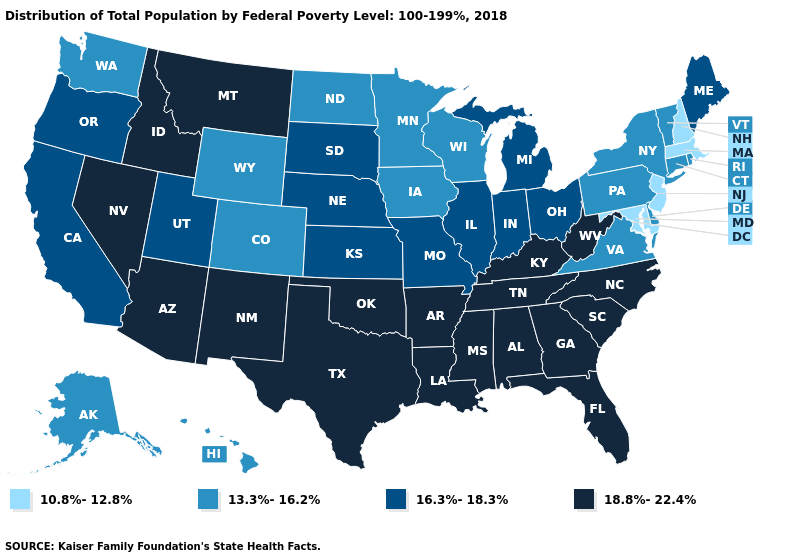Among the states that border Wisconsin , which have the highest value?
Short answer required. Illinois, Michigan. What is the highest value in the Northeast ?
Be succinct. 16.3%-18.3%. Does Indiana have the same value as New Hampshire?
Quick response, please. No. Does the map have missing data?
Keep it brief. No. Name the states that have a value in the range 13.3%-16.2%?
Short answer required. Alaska, Colorado, Connecticut, Delaware, Hawaii, Iowa, Minnesota, New York, North Dakota, Pennsylvania, Rhode Island, Vermont, Virginia, Washington, Wisconsin, Wyoming. Name the states that have a value in the range 13.3%-16.2%?
Write a very short answer. Alaska, Colorado, Connecticut, Delaware, Hawaii, Iowa, Minnesota, New York, North Dakota, Pennsylvania, Rhode Island, Vermont, Virginia, Washington, Wisconsin, Wyoming. What is the highest value in states that border Ohio?
Answer briefly. 18.8%-22.4%. Does the map have missing data?
Short answer required. No. Name the states that have a value in the range 13.3%-16.2%?
Give a very brief answer. Alaska, Colorado, Connecticut, Delaware, Hawaii, Iowa, Minnesota, New York, North Dakota, Pennsylvania, Rhode Island, Vermont, Virginia, Washington, Wisconsin, Wyoming. Name the states that have a value in the range 16.3%-18.3%?
Write a very short answer. California, Illinois, Indiana, Kansas, Maine, Michigan, Missouri, Nebraska, Ohio, Oregon, South Dakota, Utah. Among the states that border Connecticut , does Massachusetts have the highest value?
Write a very short answer. No. What is the lowest value in the West?
Keep it brief. 13.3%-16.2%. Name the states that have a value in the range 10.8%-12.8%?
Quick response, please. Maryland, Massachusetts, New Hampshire, New Jersey. Name the states that have a value in the range 18.8%-22.4%?
Answer briefly. Alabama, Arizona, Arkansas, Florida, Georgia, Idaho, Kentucky, Louisiana, Mississippi, Montana, Nevada, New Mexico, North Carolina, Oklahoma, South Carolina, Tennessee, Texas, West Virginia. Does New Jersey have the lowest value in the USA?
Quick response, please. Yes. 